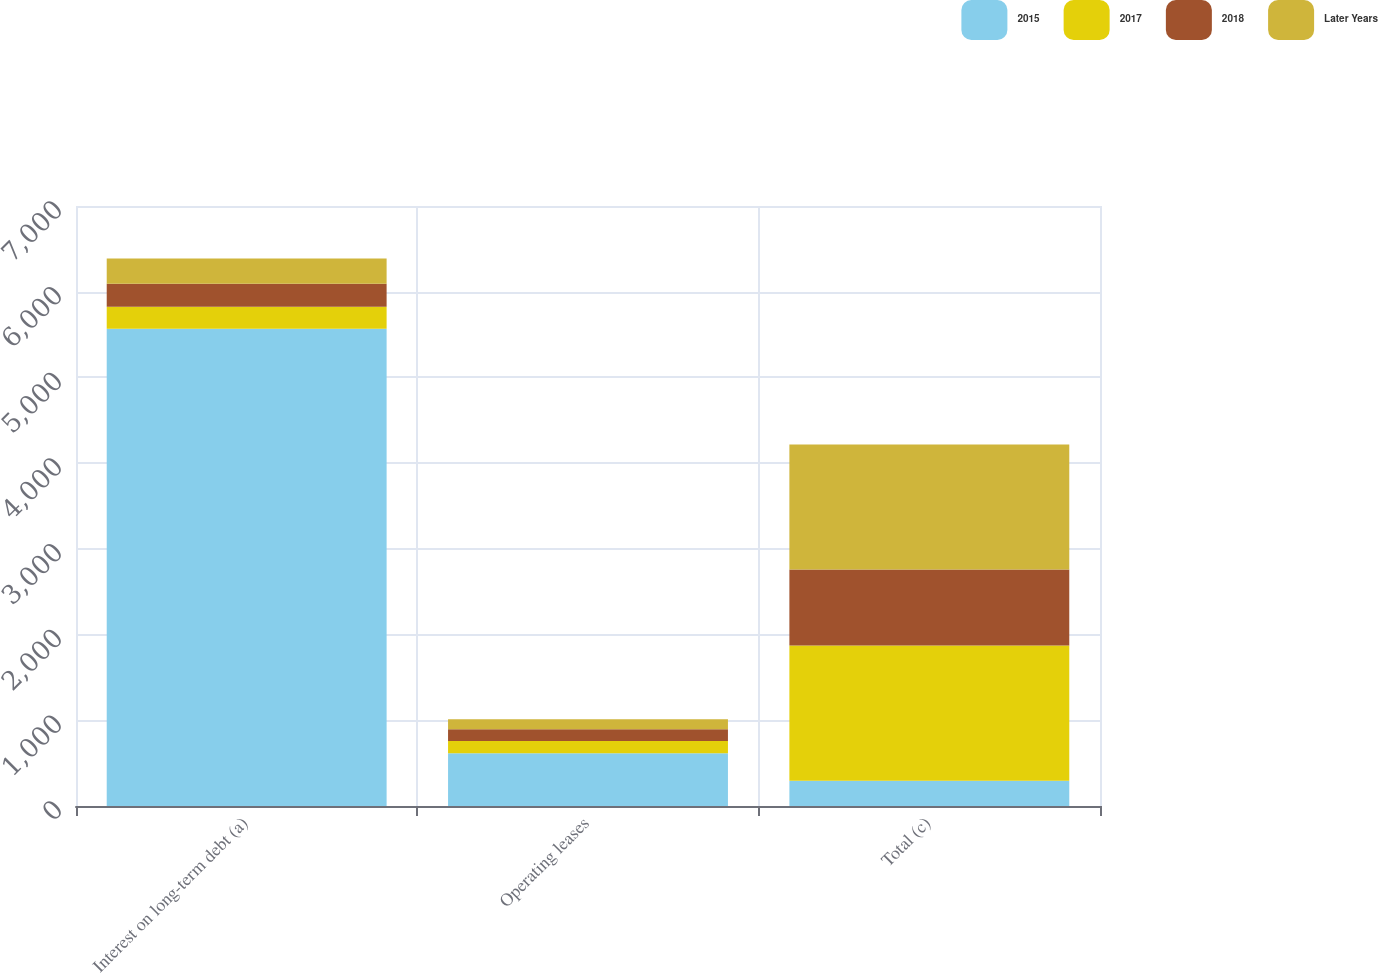<chart> <loc_0><loc_0><loc_500><loc_500><stacked_bar_chart><ecel><fcel>Interest on long-term debt (a)<fcel>Operating leases<fcel>Total (c)<nl><fcel>2015<fcel>5567<fcel>614<fcel>294<nl><fcel>2017<fcel>257<fcel>145<fcel>1578<nl><fcel>2018<fcel>269<fcel>137<fcel>886<nl><fcel>Later Years<fcel>294<fcel>117<fcel>1459<nl></chart> 